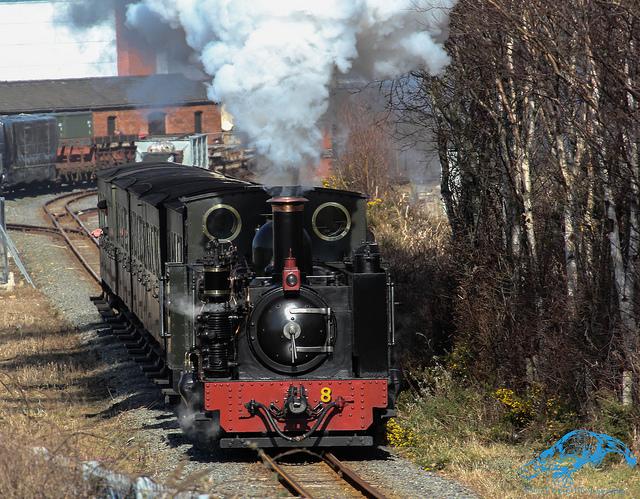Did the train need to make a turn?
Short answer required. Yes. What color is the train?
Short answer required. Black. What is coming out of the top of the train?
Concise answer only. Steam. What number can be seen on the train?
Write a very short answer. 8. 